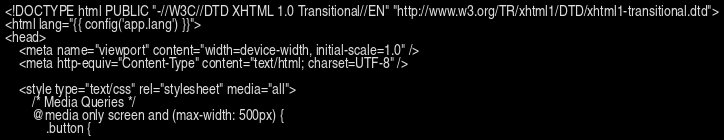<code> <loc_0><loc_0><loc_500><loc_500><_PHP_><!DOCTYPE html PUBLIC "-//W3C//DTD XHTML 1.0 Transitional//EN" "http://www.w3.org/TR/xhtml1/DTD/xhtml1-transitional.dtd">
<html lang="{{ config('app.lang') }}">
<head>
    <meta name="viewport" content="width=device-width, initial-scale=1.0" />
    <meta http-equiv="Content-Type" content="text/html; charset=UTF-8" />

    <style type="text/css" rel="stylesheet" media="all">
        /* Media Queries */
        @media only screen and (max-width: 500px) {
            .button {</code> 